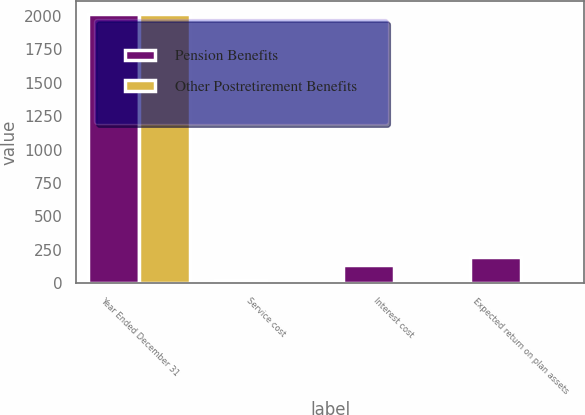Convert chart. <chart><loc_0><loc_0><loc_500><loc_500><stacked_bar_chart><ecel><fcel>Year Ended December 31<fcel>Service cost<fcel>Interest cost<fcel>Expected return on plan assets<nl><fcel>Pension Benefits<fcel>2013<fcel>22<fcel>136<fcel>198<nl><fcel>Other Postretirement Benefits<fcel>2013<fcel>1<fcel>4<fcel>5<nl></chart> 